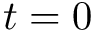<formula> <loc_0><loc_0><loc_500><loc_500>t = 0</formula> 